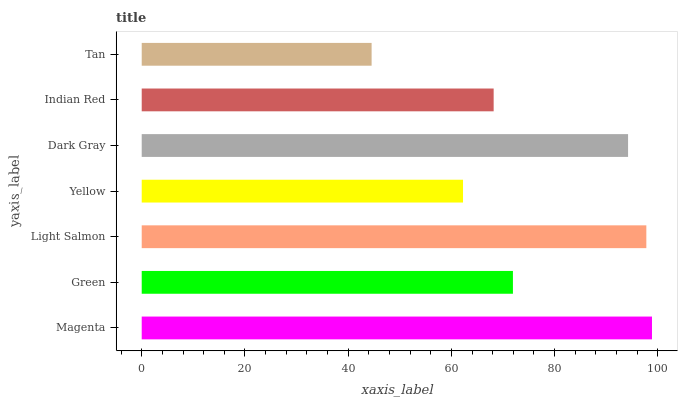Is Tan the minimum?
Answer yes or no. Yes. Is Magenta the maximum?
Answer yes or no. Yes. Is Green the minimum?
Answer yes or no. No. Is Green the maximum?
Answer yes or no. No. Is Magenta greater than Green?
Answer yes or no. Yes. Is Green less than Magenta?
Answer yes or no. Yes. Is Green greater than Magenta?
Answer yes or no. No. Is Magenta less than Green?
Answer yes or no. No. Is Green the high median?
Answer yes or no. Yes. Is Green the low median?
Answer yes or no. Yes. Is Magenta the high median?
Answer yes or no. No. Is Indian Red the low median?
Answer yes or no. No. 